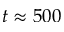<formula> <loc_0><loc_0><loc_500><loc_500>t \approx 5 0 0</formula> 